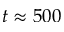<formula> <loc_0><loc_0><loc_500><loc_500>t \approx 5 0 0</formula> 